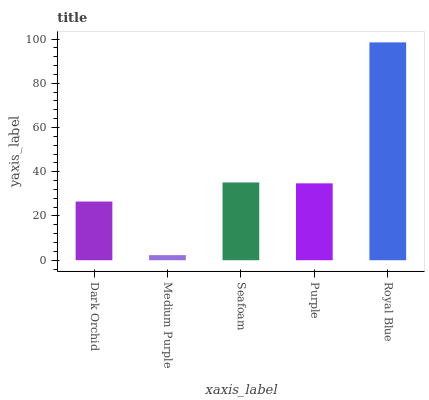Is Medium Purple the minimum?
Answer yes or no. Yes. Is Royal Blue the maximum?
Answer yes or no. Yes. Is Seafoam the minimum?
Answer yes or no. No. Is Seafoam the maximum?
Answer yes or no. No. Is Seafoam greater than Medium Purple?
Answer yes or no. Yes. Is Medium Purple less than Seafoam?
Answer yes or no. Yes. Is Medium Purple greater than Seafoam?
Answer yes or no. No. Is Seafoam less than Medium Purple?
Answer yes or no. No. Is Purple the high median?
Answer yes or no. Yes. Is Purple the low median?
Answer yes or no. Yes. Is Royal Blue the high median?
Answer yes or no. No. Is Royal Blue the low median?
Answer yes or no. No. 